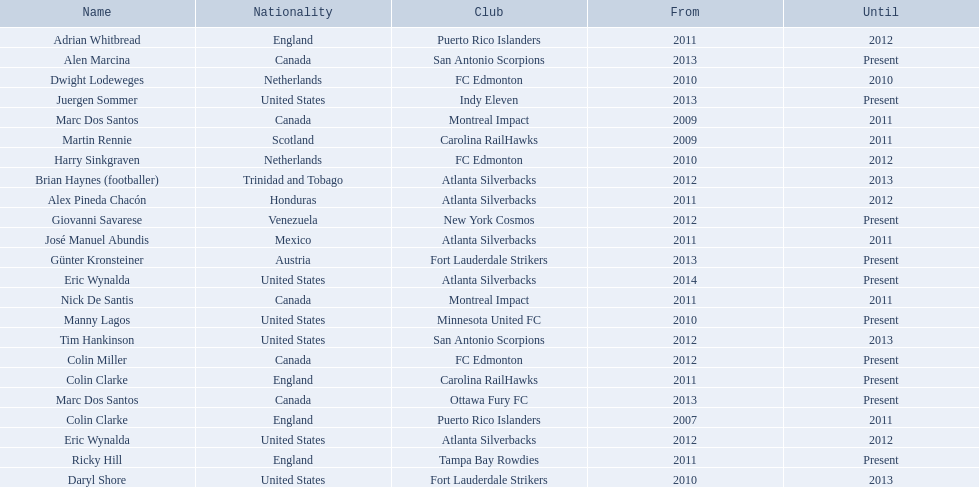What year did marc dos santos start as coach? 2009. Which other starting years correspond with this year? 2009. Who was the other coach with this starting year Martin Rennie. 